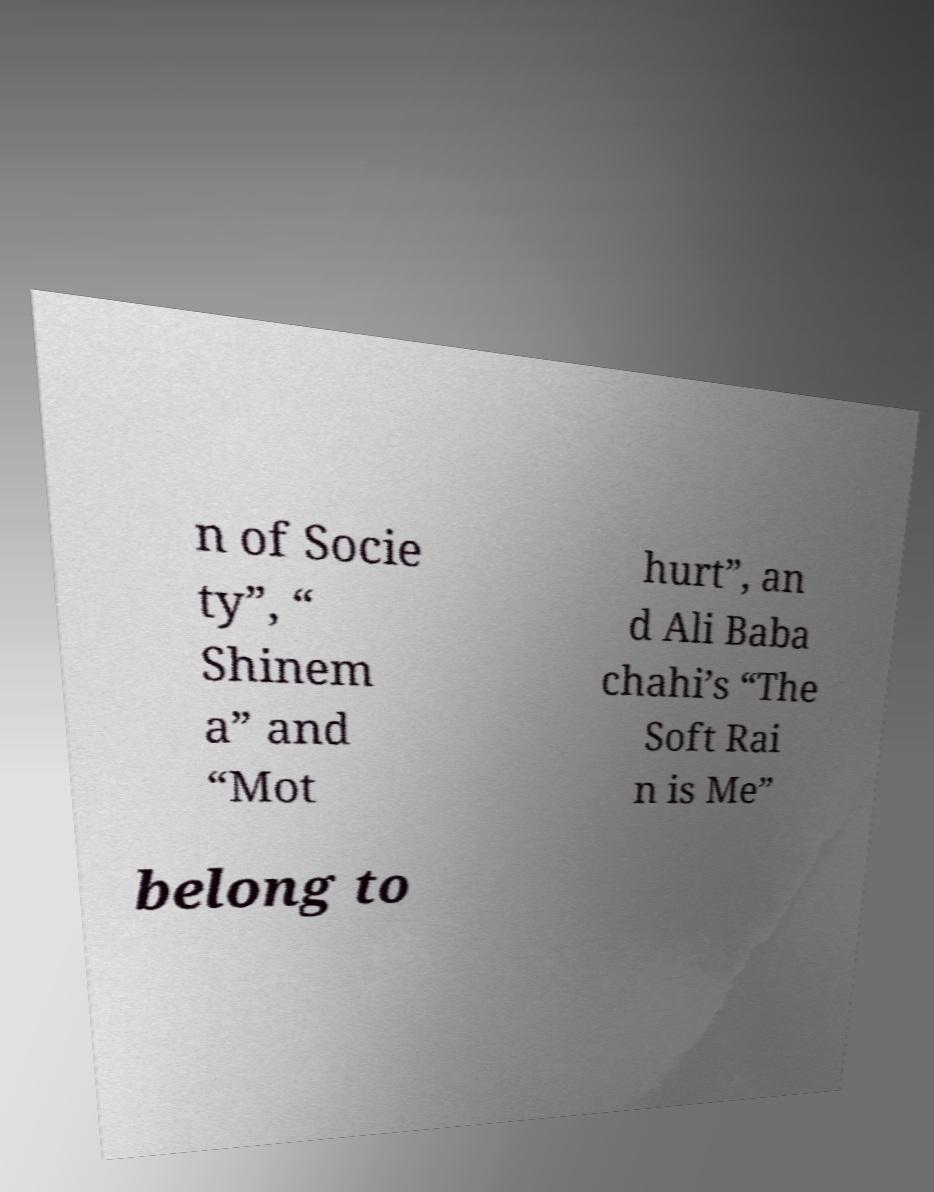Please read and relay the text visible in this image. What does it say? n of Socie ty”, “ Shinem a” and “Mot hurt”, an d Ali Baba chahi’s “The Soft Rai n is Me” belong to 